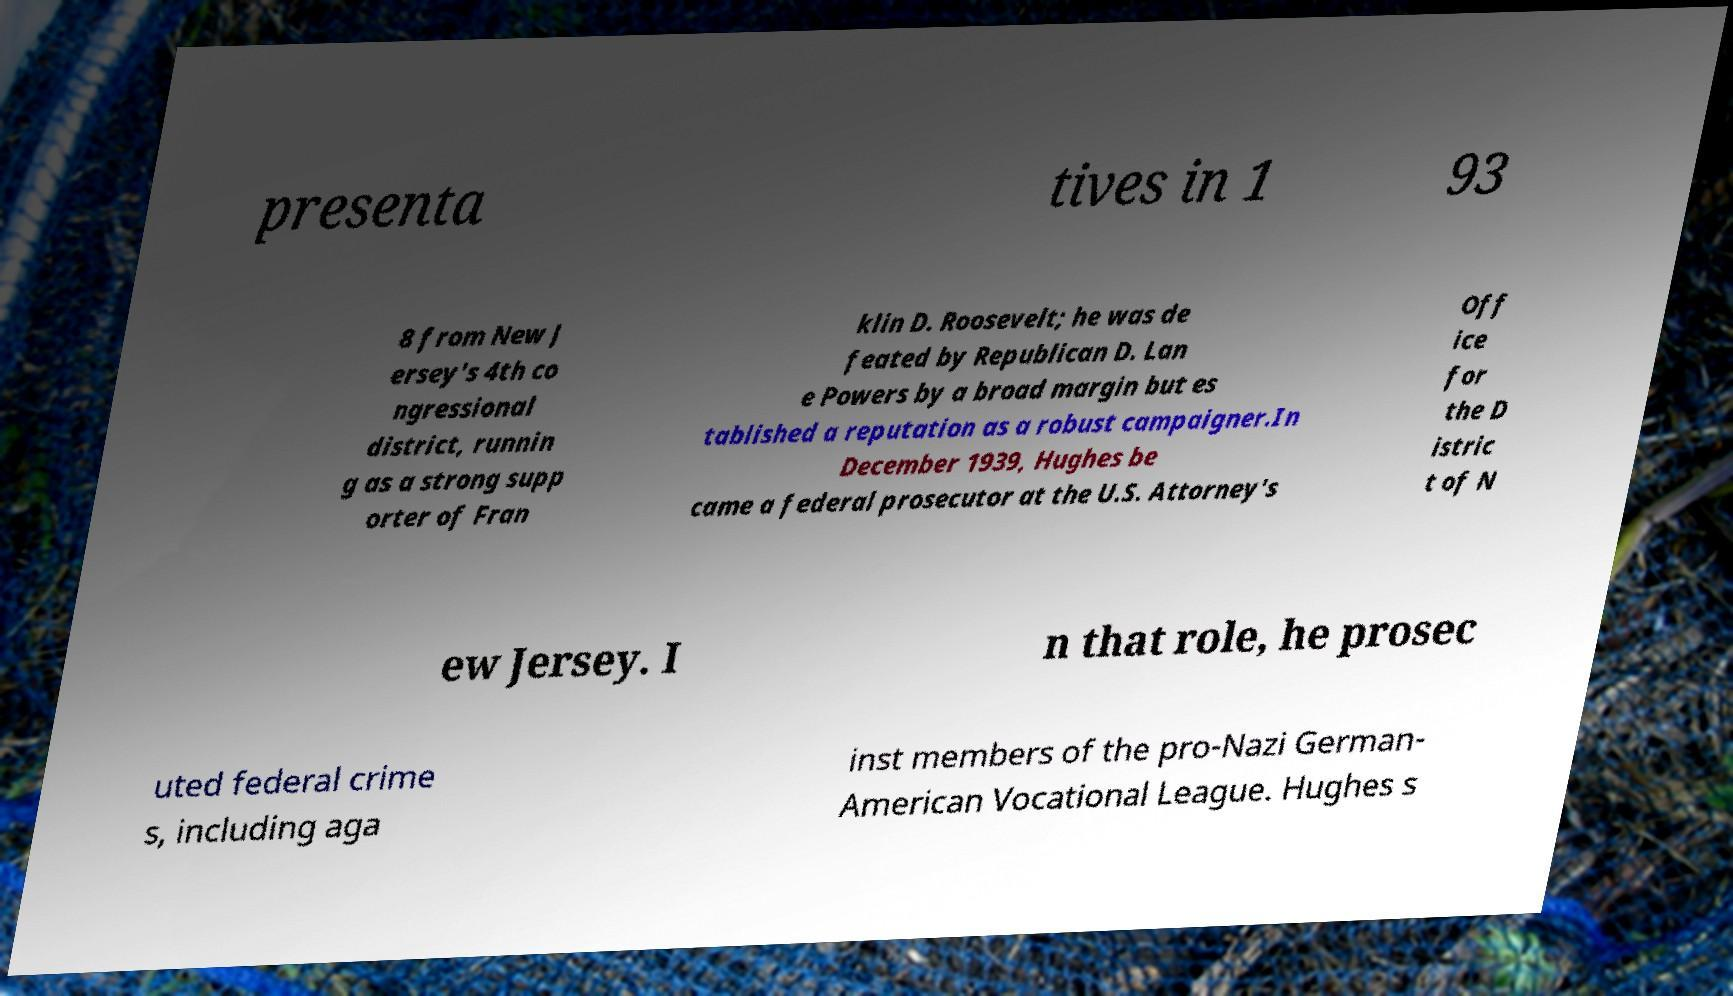Can you read and provide the text displayed in the image?This photo seems to have some interesting text. Can you extract and type it out for me? presenta tives in 1 93 8 from New J ersey's 4th co ngressional district, runnin g as a strong supp orter of Fran klin D. Roosevelt; he was de feated by Republican D. Lan e Powers by a broad margin but es tablished a reputation as a robust campaigner.In December 1939, Hughes be came a federal prosecutor at the U.S. Attorney's Off ice for the D istric t of N ew Jersey. I n that role, he prosec uted federal crime s, including aga inst members of the pro-Nazi German- American Vocational League. Hughes s 